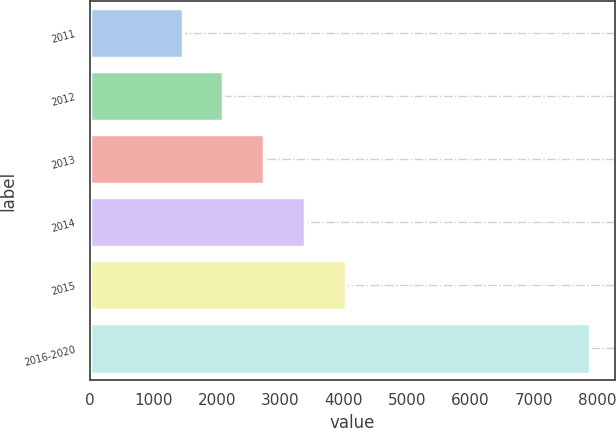<chart> <loc_0><loc_0><loc_500><loc_500><bar_chart><fcel>2011<fcel>2012<fcel>2013<fcel>2014<fcel>2015<fcel>2016-2020<nl><fcel>1460<fcel>2102.9<fcel>2745.8<fcel>3388.7<fcel>4031.6<fcel>7889<nl></chart> 